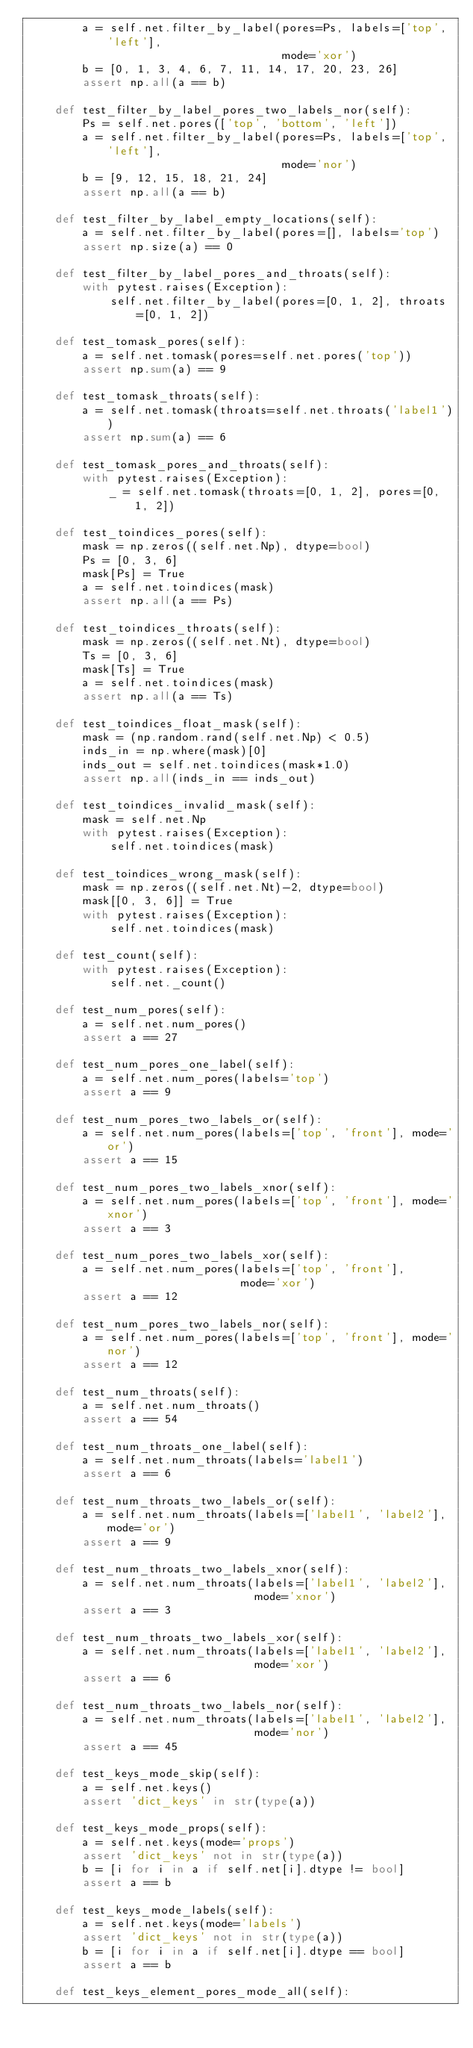Convert code to text. <code><loc_0><loc_0><loc_500><loc_500><_Python_>        a = self.net.filter_by_label(pores=Ps, labels=['top', 'left'],
                                     mode='xor')
        b = [0, 1, 3, 4, 6, 7, 11, 14, 17, 20, 23, 26]
        assert np.all(a == b)

    def test_filter_by_label_pores_two_labels_nor(self):
        Ps = self.net.pores(['top', 'bottom', 'left'])
        a = self.net.filter_by_label(pores=Ps, labels=['top', 'left'],
                                     mode='nor')
        b = [9, 12, 15, 18, 21, 24]
        assert np.all(a == b)

    def test_filter_by_label_empty_locations(self):
        a = self.net.filter_by_label(pores=[], labels='top')
        assert np.size(a) == 0

    def test_filter_by_label_pores_and_throats(self):
        with pytest.raises(Exception):
            self.net.filter_by_label(pores=[0, 1, 2], throats=[0, 1, 2])

    def test_tomask_pores(self):
        a = self.net.tomask(pores=self.net.pores('top'))
        assert np.sum(a) == 9

    def test_tomask_throats(self):
        a = self.net.tomask(throats=self.net.throats('label1'))
        assert np.sum(a) == 6

    def test_tomask_pores_and_throats(self):
        with pytest.raises(Exception):
            _ = self.net.tomask(throats=[0, 1, 2], pores=[0, 1, 2])

    def test_toindices_pores(self):
        mask = np.zeros((self.net.Np), dtype=bool)
        Ps = [0, 3, 6]
        mask[Ps] = True
        a = self.net.toindices(mask)
        assert np.all(a == Ps)

    def test_toindices_throats(self):
        mask = np.zeros((self.net.Nt), dtype=bool)
        Ts = [0, 3, 6]
        mask[Ts] = True
        a = self.net.toindices(mask)
        assert np.all(a == Ts)

    def test_toindices_float_mask(self):
        mask = (np.random.rand(self.net.Np) < 0.5)
        inds_in = np.where(mask)[0]
        inds_out = self.net.toindices(mask*1.0)
        assert np.all(inds_in == inds_out)

    def test_toindices_invalid_mask(self):
        mask = self.net.Np
        with pytest.raises(Exception):
            self.net.toindices(mask)

    def test_toindices_wrong_mask(self):
        mask = np.zeros((self.net.Nt)-2, dtype=bool)
        mask[[0, 3, 6]] = True
        with pytest.raises(Exception):
            self.net.toindices(mask)

    def test_count(self):
        with pytest.raises(Exception):
            self.net._count()

    def test_num_pores(self):
        a = self.net.num_pores()
        assert a == 27

    def test_num_pores_one_label(self):
        a = self.net.num_pores(labels='top')
        assert a == 9

    def test_num_pores_two_labels_or(self):
        a = self.net.num_pores(labels=['top', 'front'], mode='or')
        assert a == 15

    def test_num_pores_two_labels_xnor(self):
        a = self.net.num_pores(labels=['top', 'front'], mode='xnor')
        assert a == 3

    def test_num_pores_two_labels_xor(self):
        a = self.net.num_pores(labels=['top', 'front'],
                               mode='xor')
        assert a == 12

    def test_num_pores_two_labels_nor(self):
        a = self.net.num_pores(labels=['top', 'front'], mode='nor')
        assert a == 12

    def test_num_throats(self):
        a = self.net.num_throats()
        assert a == 54

    def test_num_throats_one_label(self):
        a = self.net.num_throats(labels='label1')
        assert a == 6

    def test_num_throats_two_labels_or(self):
        a = self.net.num_throats(labels=['label1', 'label2'], mode='or')
        assert a == 9

    def test_num_throats_two_labels_xnor(self):
        a = self.net.num_throats(labels=['label1', 'label2'],
                                 mode='xnor')
        assert a == 3

    def test_num_throats_two_labels_xor(self):
        a = self.net.num_throats(labels=['label1', 'label2'],
                                 mode='xor')
        assert a == 6

    def test_num_throats_two_labels_nor(self):
        a = self.net.num_throats(labels=['label1', 'label2'],
                                 mode='nor')
        assert a == 45

    def test_keys_mode_skip(self):
        a = self.net.keys()
        assert 'dict_keys' in str(type(a))

    def test_keys_mode_props(self):
        a = self.net.keys(mode='props')
        assert 'dict_keys' not in str(type(a))
        b = [i for i in a if self.net[i].dtype != bool]
        assert a == b

    def test_keys_mode_labels(self):
        a = self.net.keys(mode='labels')
        assert 'dict_keys' not in str(type(a))
        b = [i for i in a if self.net[i].dtype == bool]
        assert a == b

    def test_keys_element_pores_mode_all(self):</code> 